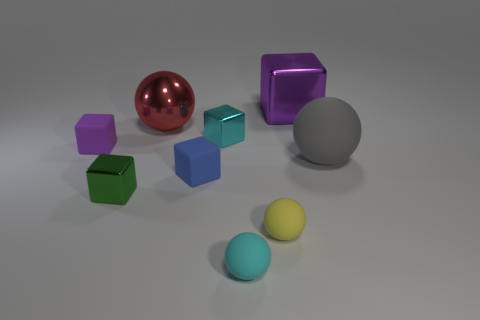There is a gray object; how many small rubber cubes are in front of it?
Make the answer very short. 1. What shape is the cyan thing that is the same material as the large gray sphere?
Ensure brevity in your answer.  Sphere. Is the shape of the small cyan object that is in front of the small yellow rubber ball the same as  the big gray object?
Offer a terse response. Yes. What number of cyan things are either tiny rubber objects or tiny metal cubes?
Provide a short and direct response. 2. Is the number of cyan shiny things right of the big red metallic object the same as the number of rubber balls in front of the big gray matte object?
Offer a terse response. No. There is a tiny metallic block that is in front of the purple cube that is in front of the metal thing on the right side of the cyan metal thing; what is its color?
Your response must be concise. Green. Are there any other things of the same color as the large metal cube?
Your response must be concise. Yes. There is a object that is the same color as the big metallic cube; what shape is it?
Provide a short and direct response. Cube. What size is the thing that is to the right of the big purple shiny block?
Your answer should be very brief. Large. The yellow matte object that is the same size as the blue rubber cube is what shape?
Make the answer very short. Sphere. 